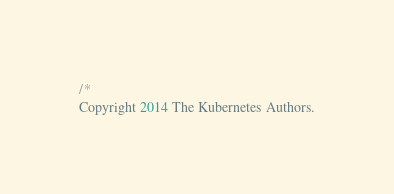Convert code to text. <code><loc_0><loc_0><loc_500><loc_500><_Go_>/*
Copyright 2014 The Kubernetes Authors.
</code> 